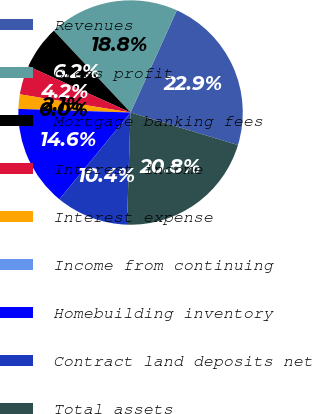Convert chart. <chart><loc_0><loc_0><loc_500><loc_500><pie_chart><fcel>Revenues<fcel>Gross profit<fcel>Mortgage banking fees<fcel>Interest income<fcel>Interest expense<fcel>Income from continuing<fcel>Homebuilding inventory<fcel>Contract land deposits net<fcel>Total assets<nl><fcel>22.92%<fcel>18.75%<fcel>6.25%<fcel>4.17%<fcel>2.08%<fcel>0.0%<fcel>14.58%<fcel>10.42%<fcel>20.83%<nl></chart> 